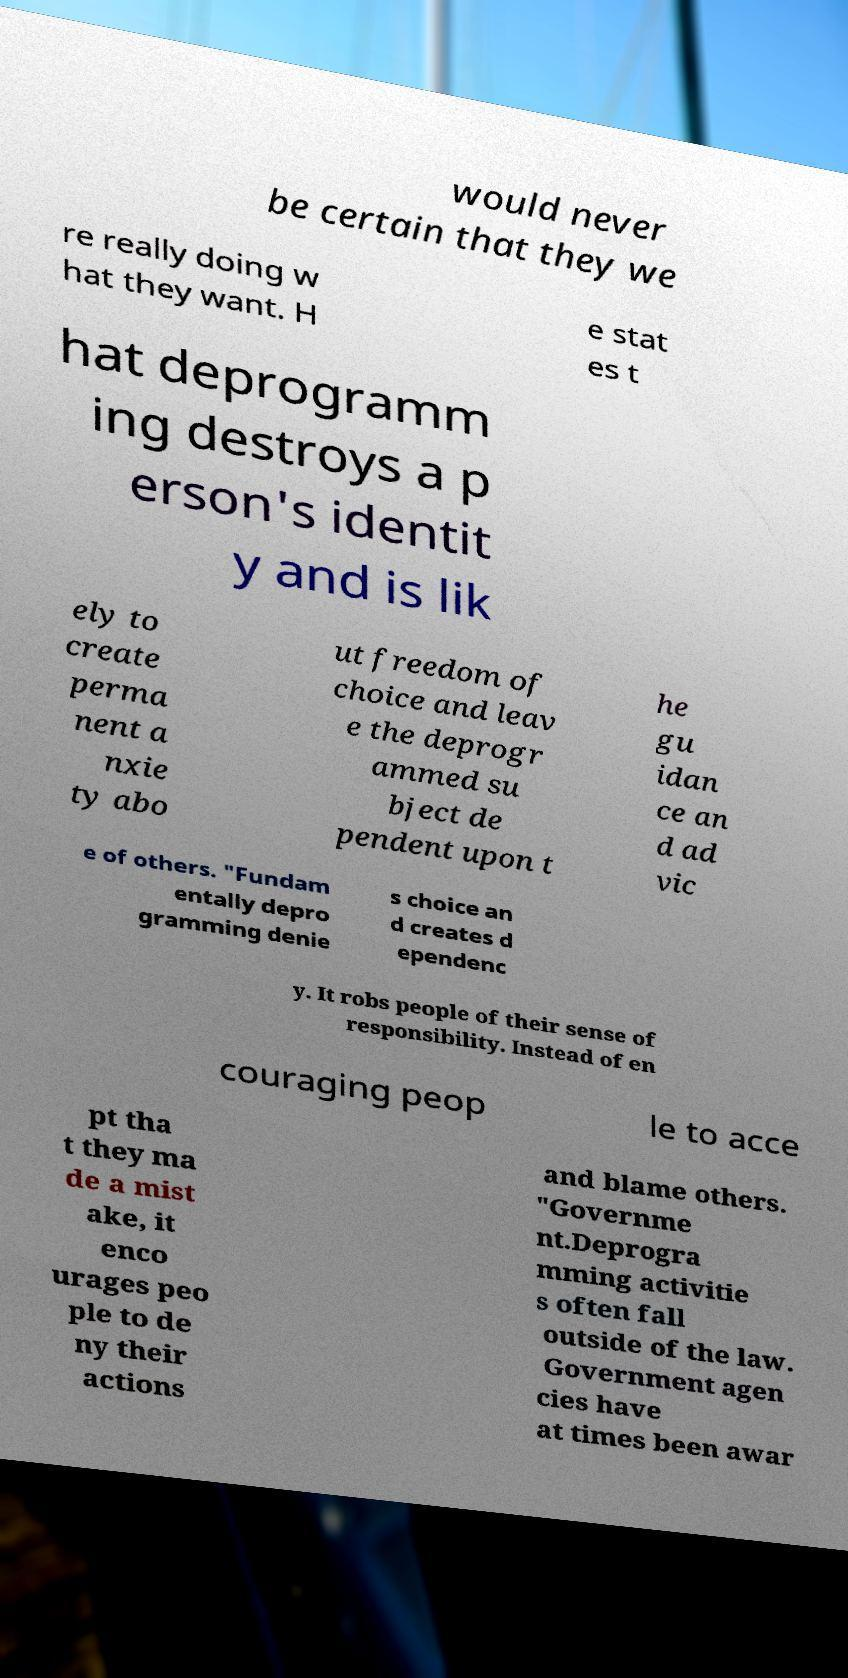Could you extract and type out the text from this image? would never be certain that they we re really doing w hat they want. H e stat es t hat deprogramm ing destroys a p erson's identit y and is lik ely to create perma nent a nxie ty abo ut freedom of choice and leav e the deprogr ammed su bject de pendent upon t he gu idan ce an d ad vic e of others. "Fundam entally depro gramming denie s choice an d creates d ependenc y. It robs people of their sense of responsibility. Instead of en couraging peop le to acce pt tha t they ma de a mist ake, it enco urages peo ple to de ny their actions and blame others. "Governme nt.Deprogra mming activitie s often fall outside of the law. Government agen cies have at times been awar 